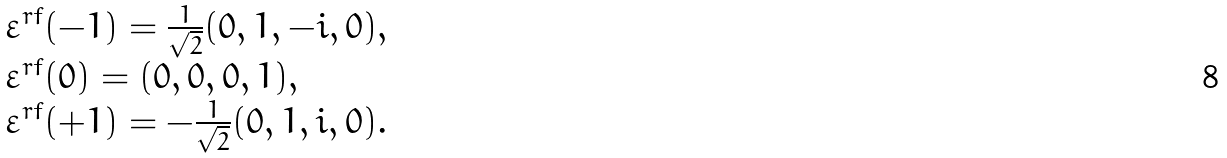Convert formula to latex. <formula><loc_0><loc_0><loc_500><loc_500>\begin{array} { l } { { \varepsilon ^ { r f } ( - 1 ) = \frac { 1 } { \sqrt { 2 } } ( 0 , 1 , - i , 0 ) , } } \\ { { \varepsilon ^ { r f } ( 0 ) = ( 0 , 0 , 0 , 1 ) , } } \\ { { \varepsilon ^ { r f } ( + 1 ) = - \frac { 1 } { \sqrt { 2 } } ( 0 , 1 , i , 0 ) . } } \end{array}</formula> 